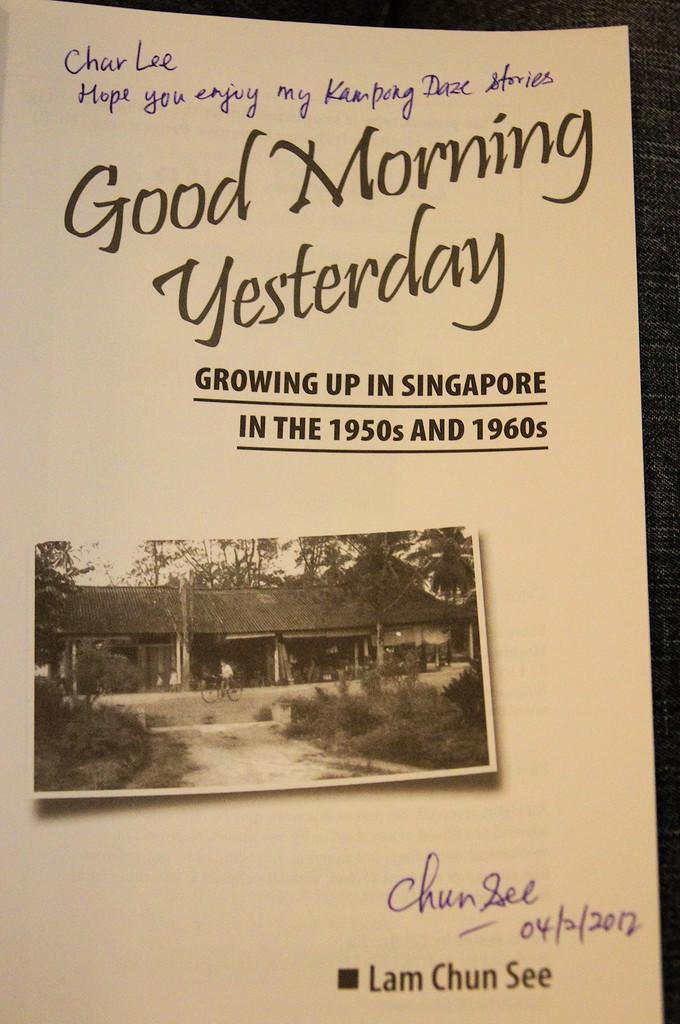What is the main feature of the image? There is a poster in the image. What types of content are present on the poster? The poster contains words, numbers, and various images, including a house, trees, plants, the sky, and a person riding a bicycle. Can you describe the background of the image? There is a cloth-like object in the background of the image. What is the opinion of the vein in the image? There is no vein present in the image, so it is not possible to determine its opinion. 